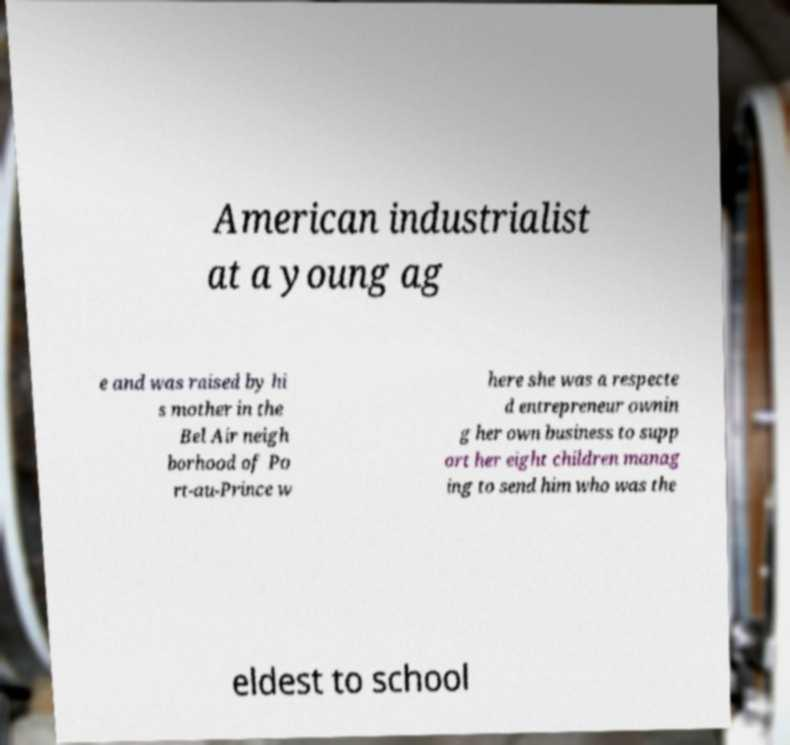Please read and relay the text visible in this image. What does it say? American industrialist at a young ag e and was raised by hi s mother in the Bel Air neigh borhood of Po rt-au-Prince w here she was a respecte d entrepreneur ownin g her own business to supp ort her eight children manag ing to send him who was the eldest to school 